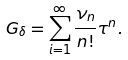Convert formula to latex. <formula><loc_0><loc_0><loc_500><loc_500>G _ { \delta } = \sum _ { i = 1 } ^ { \infty } \frac { \nu _ { n } } { n ! } \tau ^ { n } .</formula> 